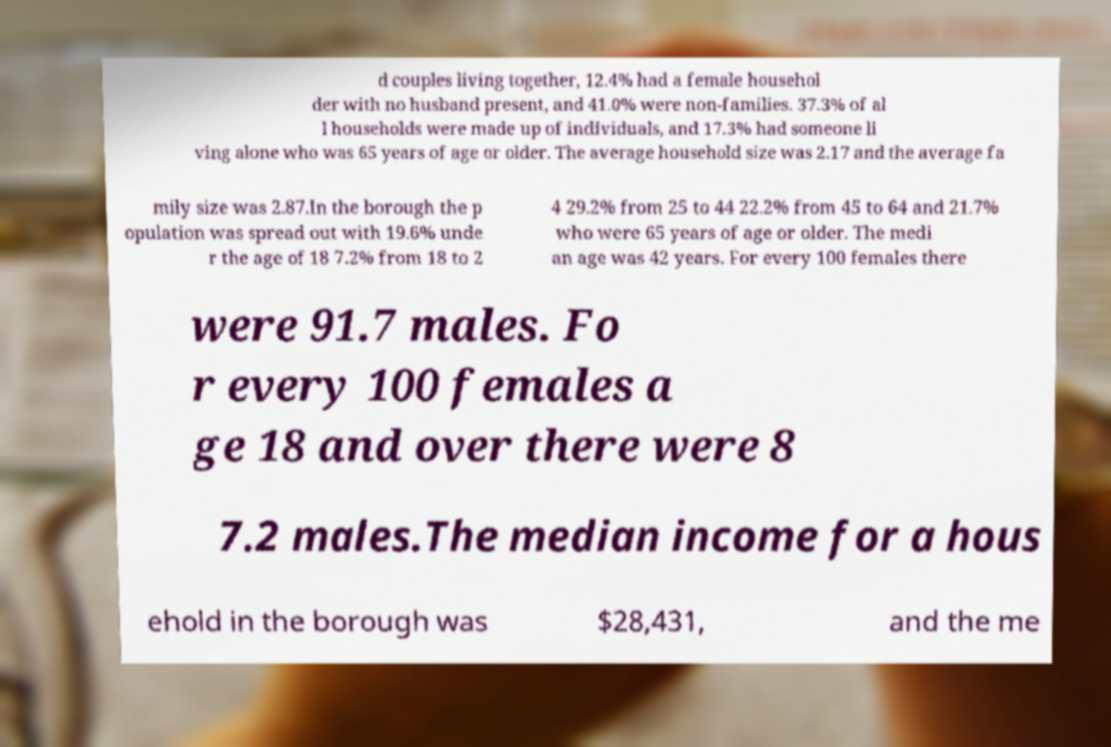Could you assist in decoding the text presented in this image and type it out clearly? d couples living together, 12.4% had a female househol der with no husband present, and 41.0% were non-families. 37.3% of al l households were made up of individuals, and 17.3% had someone li ving alone who was 65 years of age or older. The average household size was 2.17 and the average fa mily size was 2.87.In the borough the p opulation was spread out with 19.6% unde r the age of 18 7.2% from 18 to 2 4 29.2% from 25 to 44 22.2% from 45 to 64 and 21.7% who were 65 years of age or older. The medi an age was 42 years. For every 100 females there were 91.7 males. Fo r every 100 females a ge 18 and over there were 8 7.2 males.The median income for a hous ehold in the borough was $28,431, and the me 